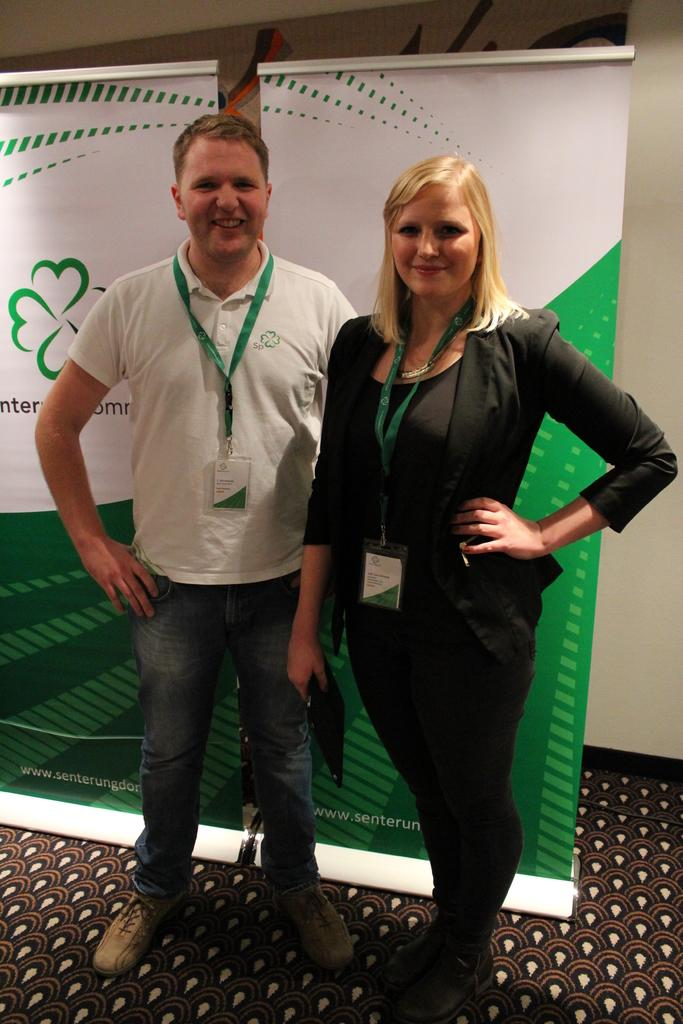Who are the people in the image? There is a woman and a man standing in the image. What are they wearing that is visible in the image? Both the woman and the man are wearing ID cards. What can be seen in the background of the image? There are banners and a wall in the background of the image. What is the floor covering in the image? The floor has a carpet. Can you see any beetles crawling on the carpet in the image? There are no beetles visible in the image; it only shows a woman, a man, and their surroundings. Is there a ghost visible in the image? There is no ghost present in the image. 